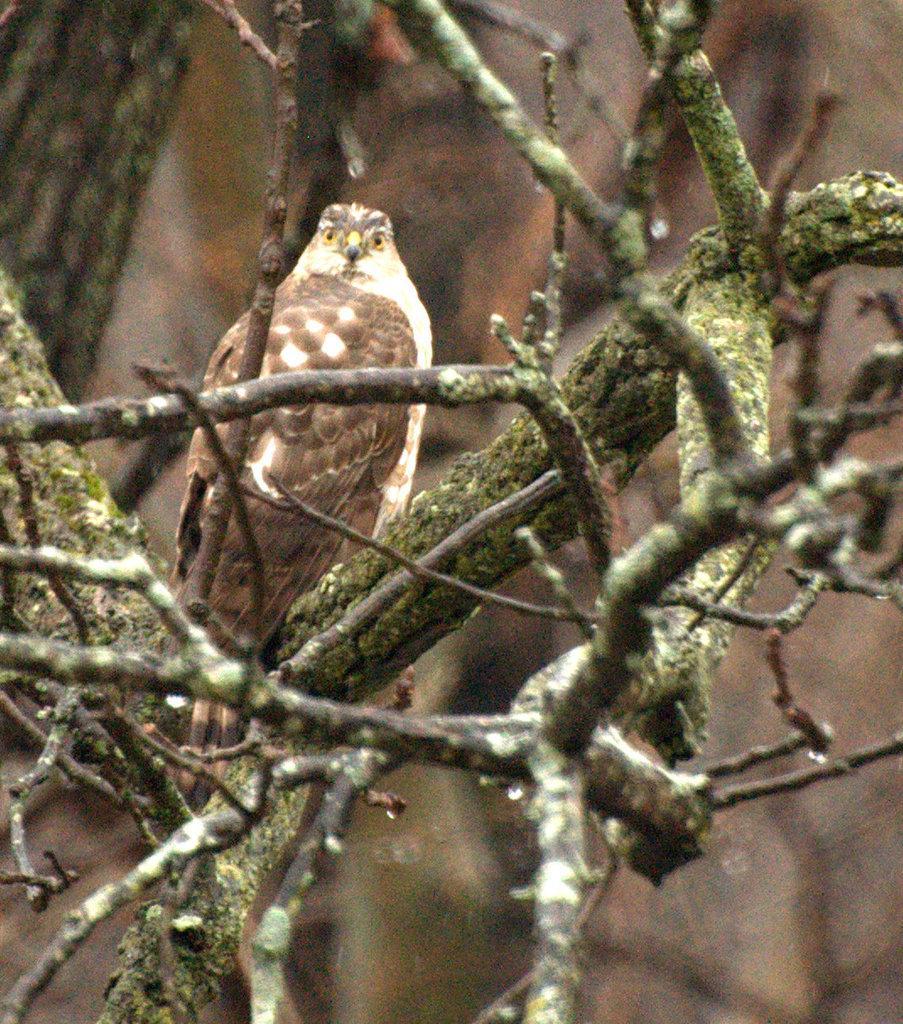Could you give a brief overview of what you see in this image? This image consists of a owl sitting on a tree. It is in brown color. In the front, we can see the stems of the tree. The background is blurred. 